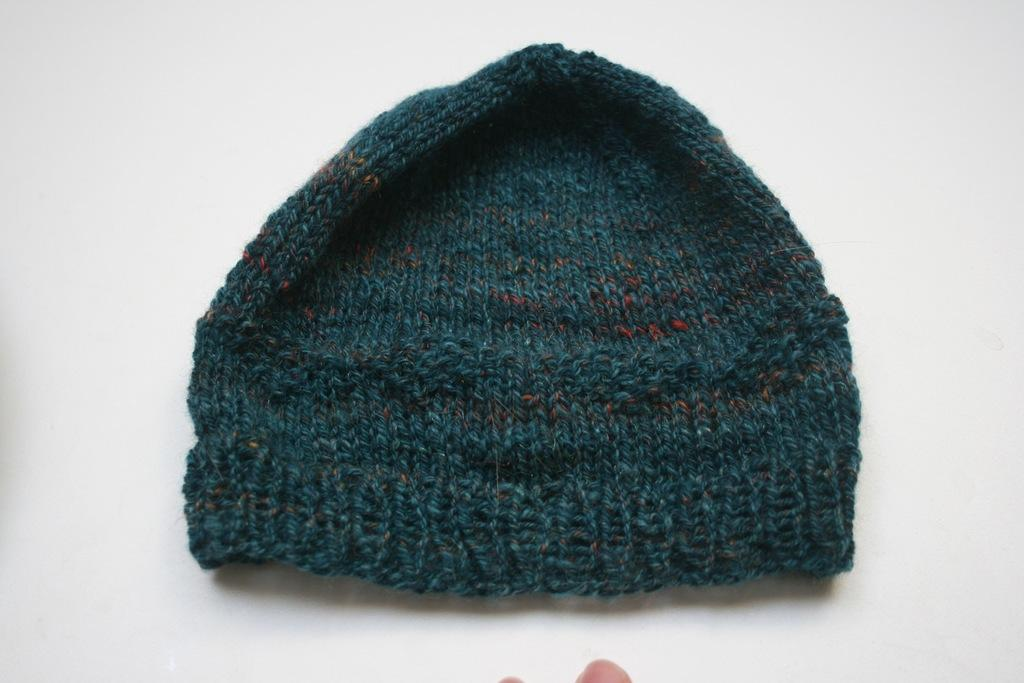What type of clothing item is in the image? There is a woolen cap in the image. Where is the woolen cap placed? The woolen cap is on a white surface. What else can be seen in the image besides the woolen cap? Human fingers are visible at the bottom of the image. What type of sofa is depicted in the image? There is no sofa present in the image. What is the purpose of the woolen cap in the image? The purpose of the woolen cap cannot be determined from the image alone, as it depends on the context in which it is being used. 